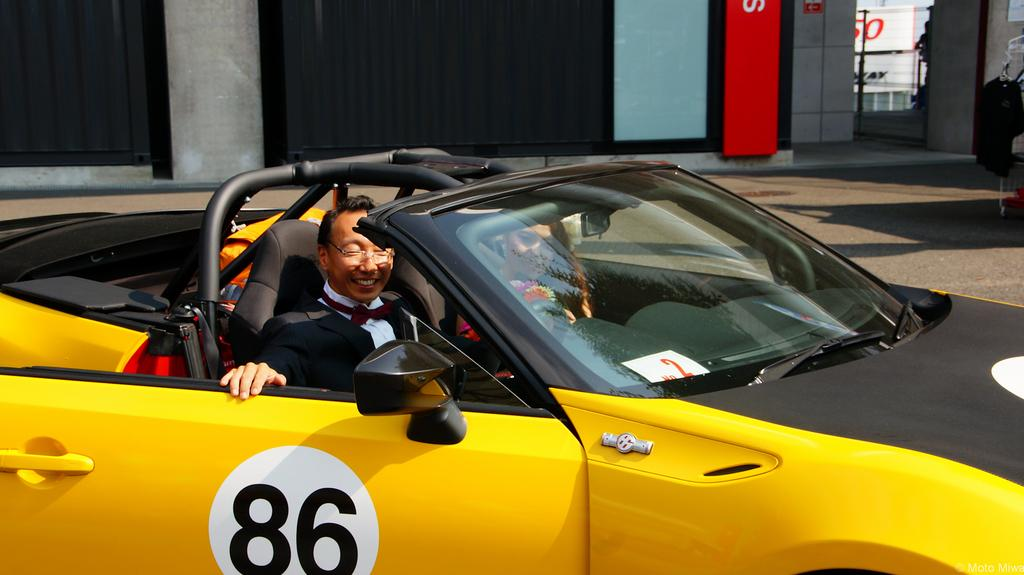What color is the car in the image? The car in the image is yellow. What number is written on the door of the car? The car has "86" written on the door. How many people are sitting in the car? There are two persons sitting in the car. What can be seen behind the car in the image? There is a building behind the car. Can you see any cherries growing on the wing of the car in the image? There is no wing or cherries present in the image; it features a yellow car with "86" written on the door and two persons sitting inside. 